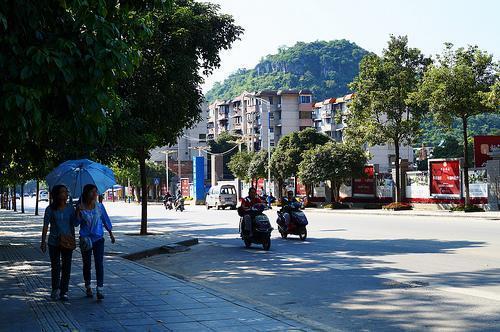How many women are walking?
Give a very brief answer. 2. How many people on the sidewalk?
Give a very brief answer. 2. 